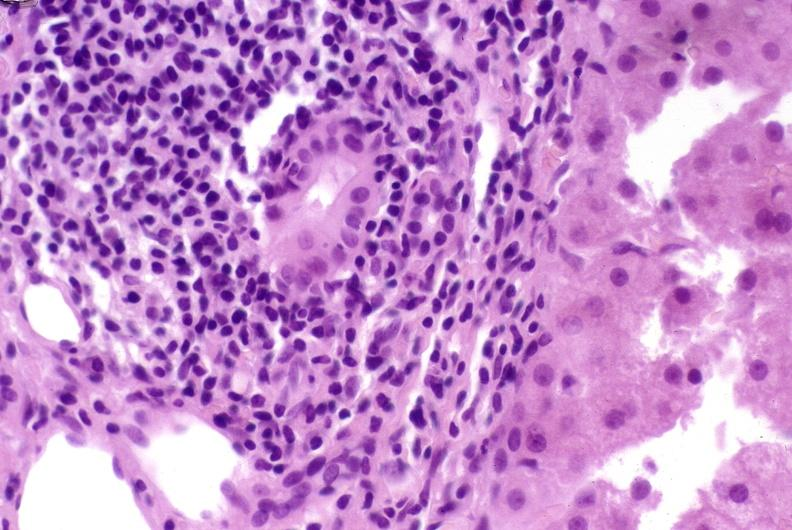does nodular tumor show post-orthotopic liver transplant?
Answer the question using a single word or phrase. No 